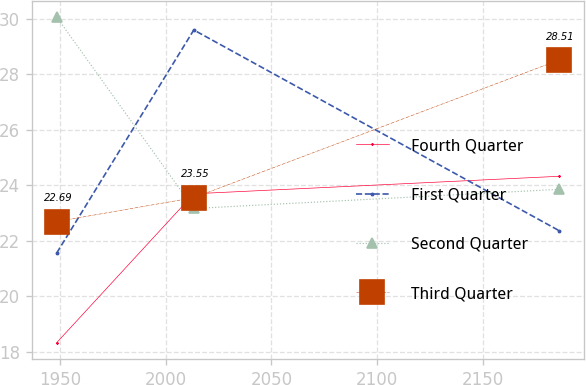<chart> <loc_0><loc_0><loc_500><loc_500><line_chart><ecel><fcel>Fourth Quarter<fcel>First Quarter<fcel>Second Quarter<fcel>Third Quarter<nl><fcel>1948.43<fcel>18.33<fcel>21.56<fcel>30.05<fcel>22.69<nl><fcel>2013.29<fcel>23.69<fcel>29.59<fcel>23.16<fcel>23.55<nl><fcel>2186.26<fcel>24.32<fcel>22.36<fcel>23.85<fcel>28.51<nl></chart> 